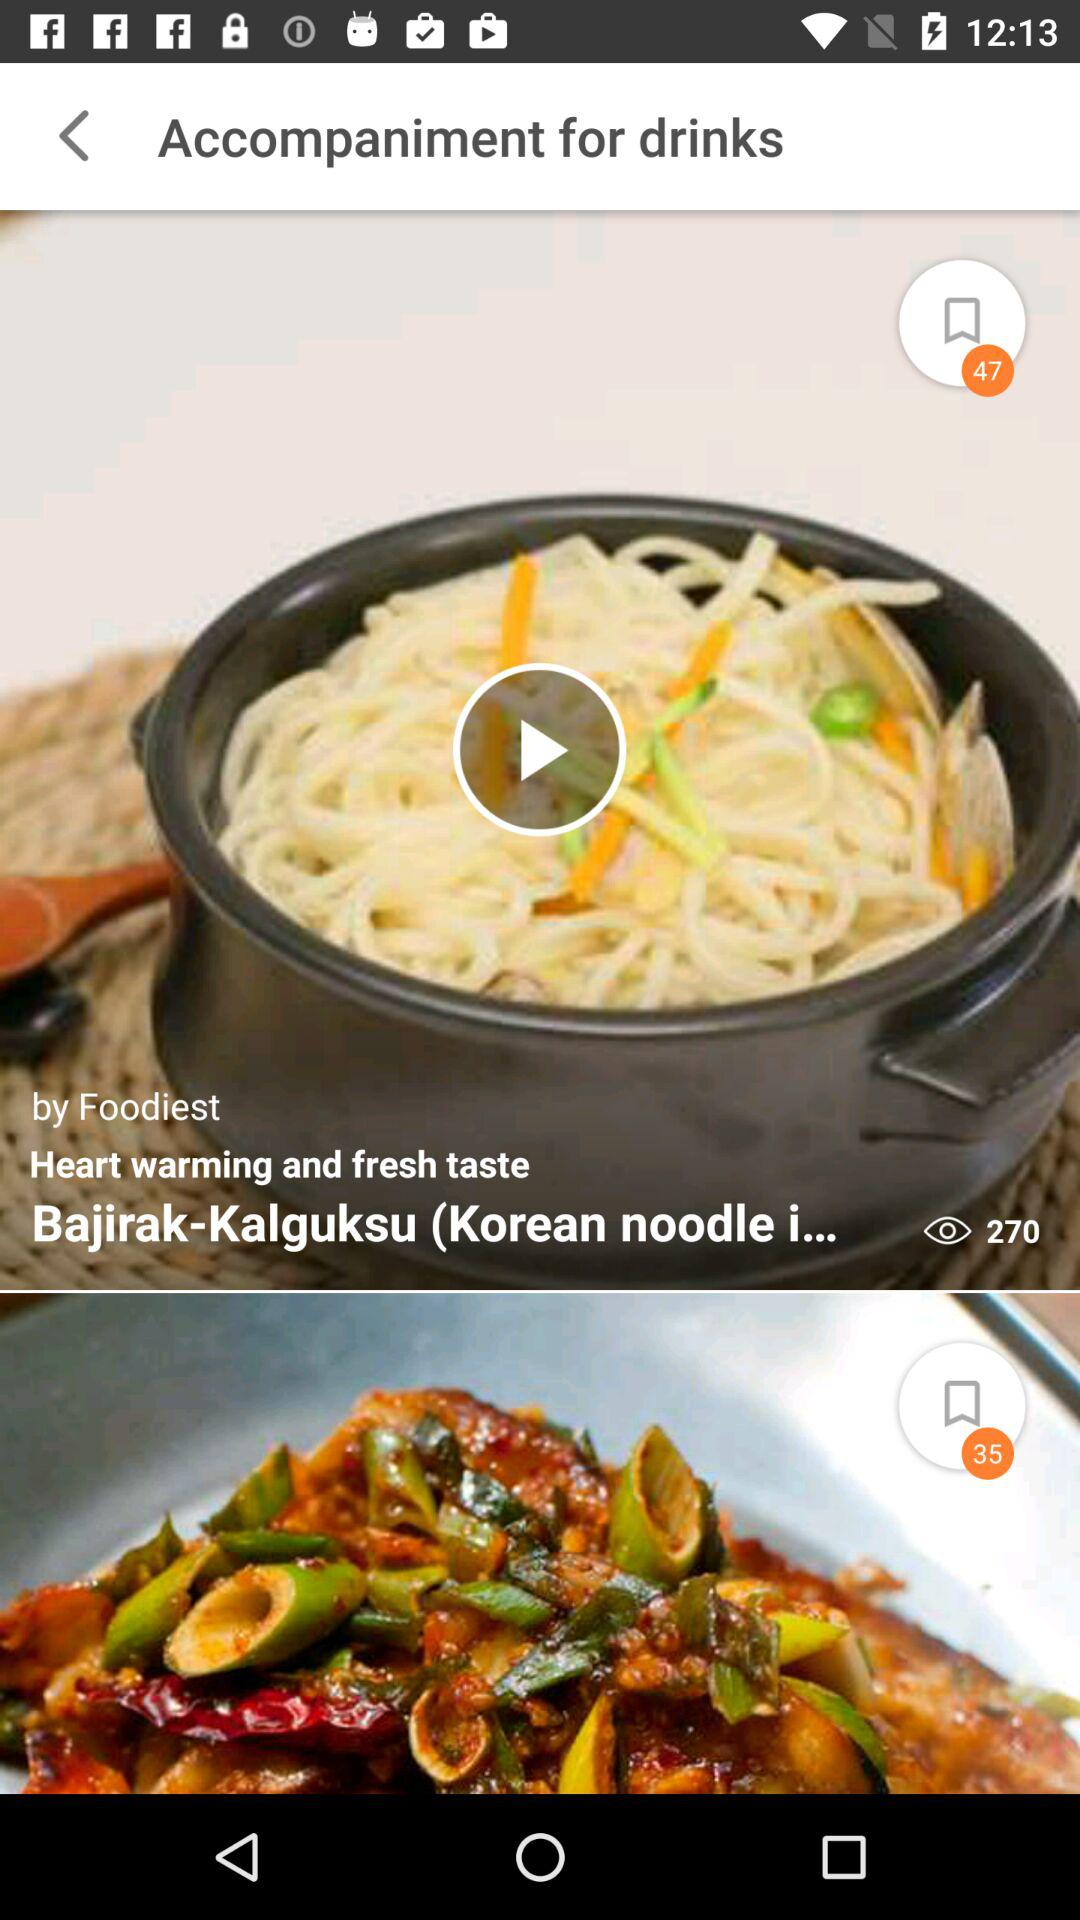What is the dish name? The dish name is "Bajirak-Kalguksu (Korean noodle i...". 